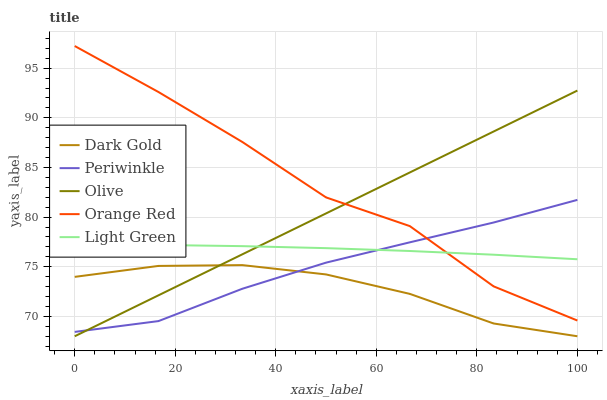Does Periwinkle have the minimum area under the curve?
Answer yes or no. No. Does Periwinkle have the maximum area under the curve?
Answer yes or no. No. Is Periwinkle the smoothest?
Answer yes or no. No. Is Periwinkle the roughest?
Answer yes or no. No. Does Periwinkle have the lowest value?
Answer yes or no. No. Does Periwinkle have the highest value?
Answer yes or no. No. Is Dark Gold less than Orange Red?
Answer yes or no. Yes. Is Light Green greater than Dark Gold?
Answer yes or no. Yes. Does Dark Gold intersect Orange Red?
Answer yes or no. No. 